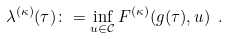Convert formula to latex. <formula><loc_0><loc_0><loc_500><loc_500>\lambda ^ { ( \kappa ) } ( \tau ) \colon = \inf _ { u \in \mathcal { C } } F ^ { ( \kappa ) } ( g ( \tau ) , u ) \ .</formula> 